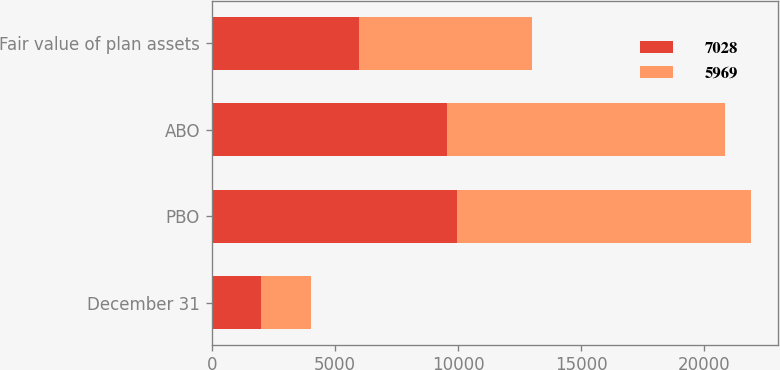Convert chart. <chart><loc_0><loc_0><loc_500><loc_500><stacked_bar_chart><ecel><fcel>December 31<fcel>PBO<fcel>ABO<fcel>Fair value of plan assets<nl><fcel>7028<fcel>2011<fcel>9960<fcel>9536<fcel>5969<nl><fcel>5969<fcel>2012<fcel>11956<fcel>11323<fcel>7028<nl></chart> 